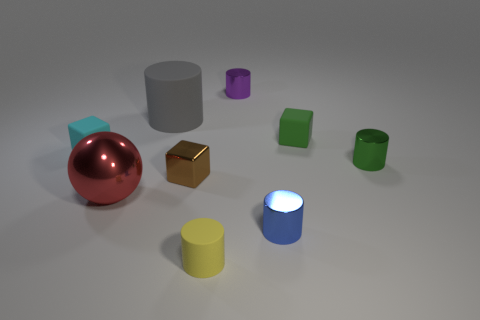How are the objects arranged in terms of colors and shapes? The objects are arranged in a scattered manner with no discernible pattern based on their colors or shapes. There's a diversity of forms including cylinders, cubes, and a sphere, with various colors such as red, blue, yellow, green, and purple. 